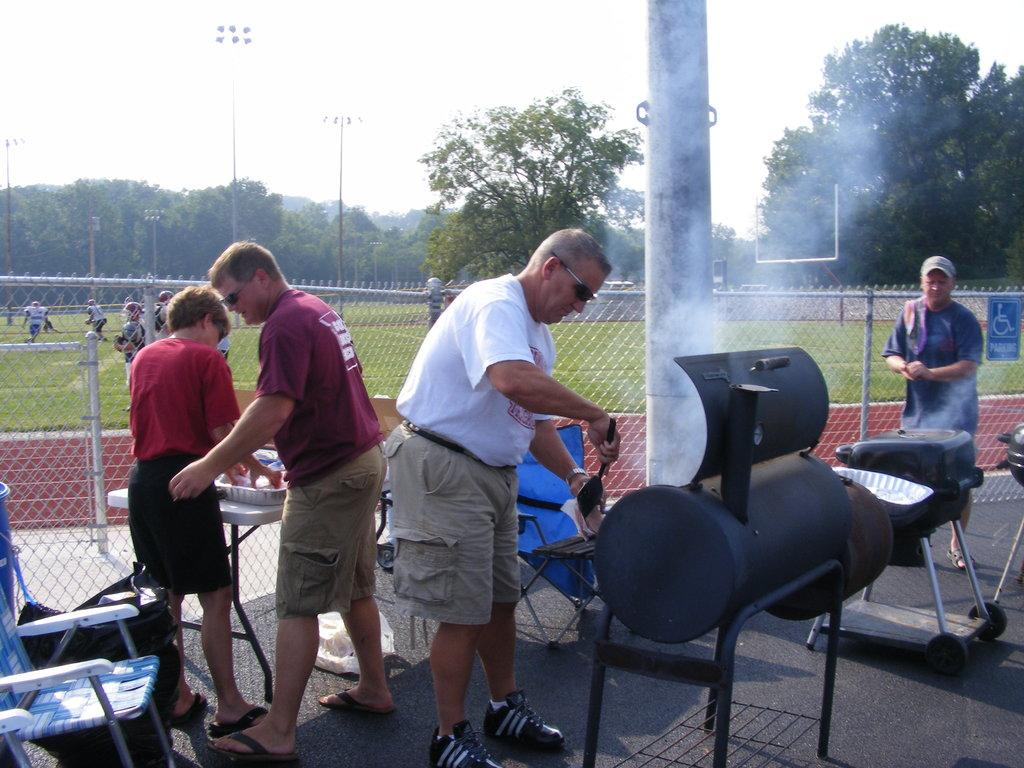Who or what can be seen in the image? There are people in the image. What furniture is visible in the image? There are chairs and a table on the ground in the image. What objects are present in the image? There are objects in the image, but their specific nature is not mentioned in the facts. What can be seen in the background of the image? In the background of the image, there is a fence, people, trees, poles, and the sky. What type of bedroom is visible in the image? There is no bedroom present in the image; it features an outdoor scene with people, furniture, and various background elements. What is the judge doing in the image? There is no judge present in the image. 